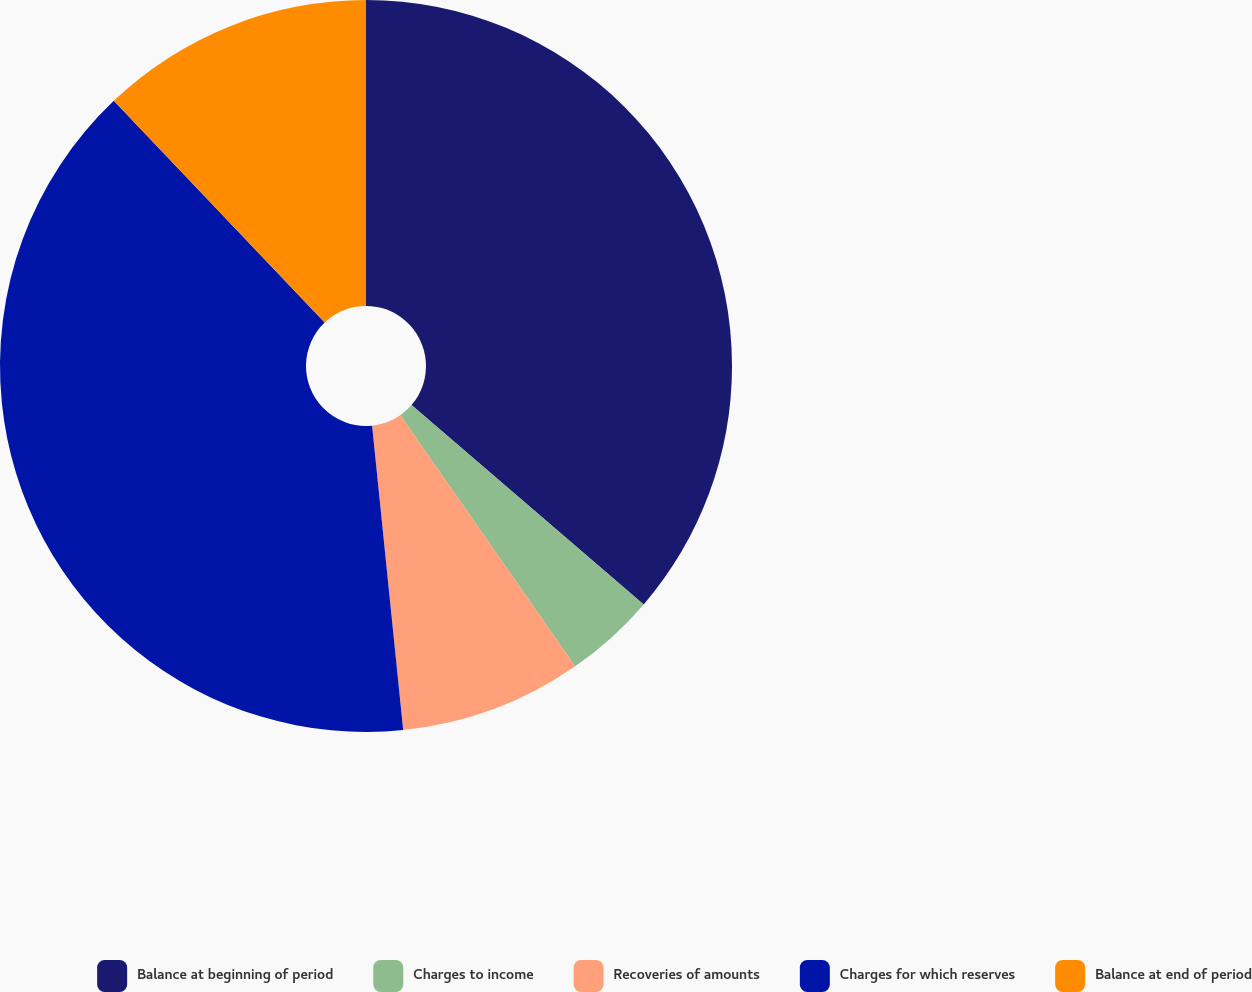Convert chart. <chart><loc_0><loc_0><loc_500><loc_500><pie_chart><fcel>Balance at beginning of period<fcel>Charges to income<fcel>Recoveries of amounts<fcel>Charges for which reserves<fcel>Balance at end of period<nl><fcel>36.29%<fcel>4.03%<fcel>8.06%<fcel>39.52%<fcel>12.1%<nl></chart> 